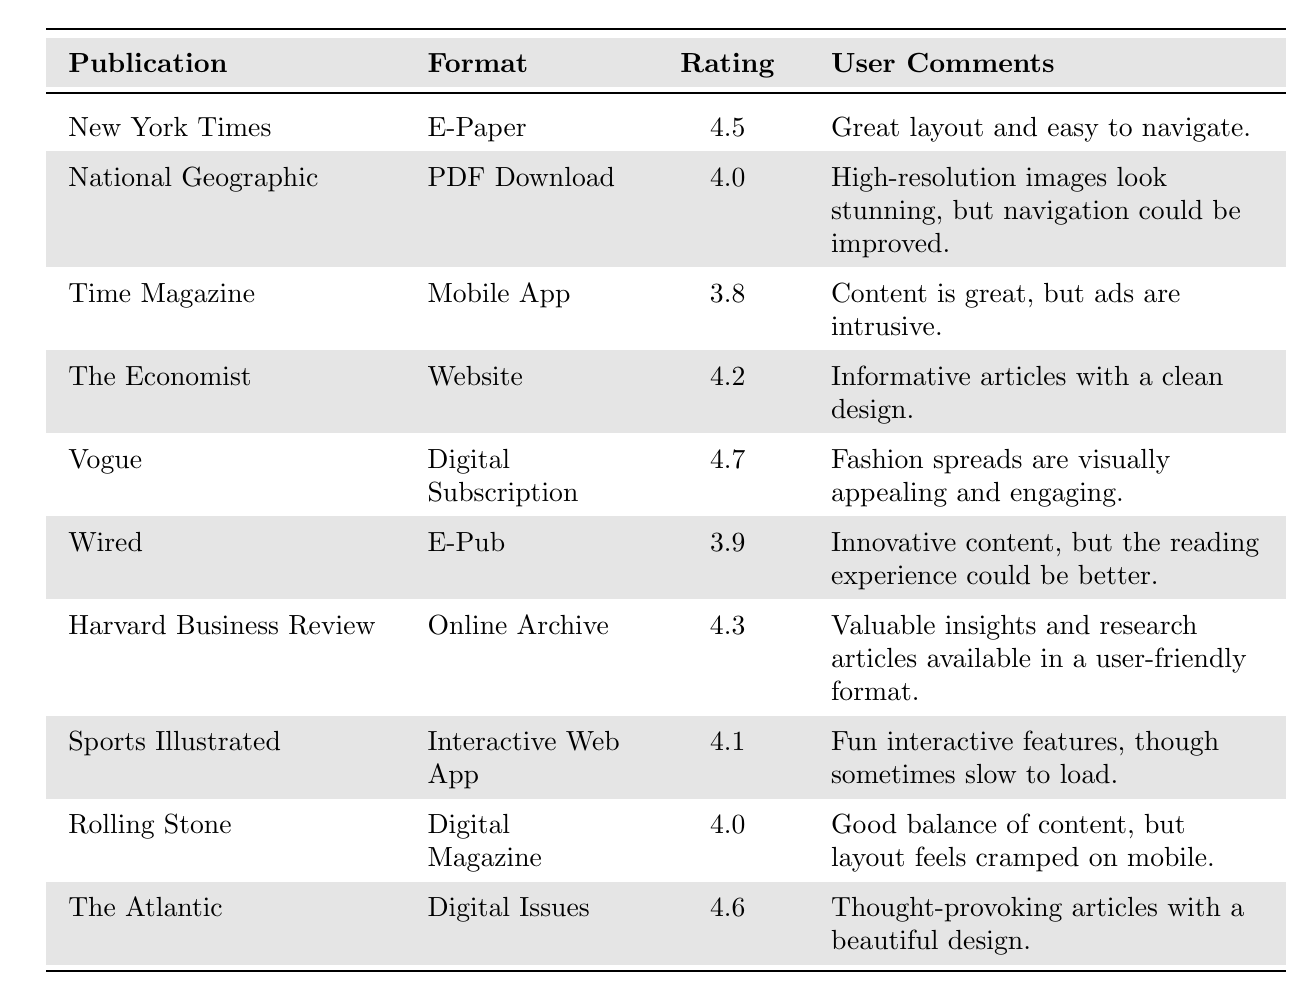What is the highest rating among the digital formats listed? The table shows ratings for each publication: 4.5 for New York Times, 4.0 for National Geographic, 3.8 for Time Magazine, 4.2 for The Economist, 4.7 for Vogue, 3.9 for Wired, 4.3 for Harvard Business Review, 4.1 for Sports Illustrated, 4.0 for Rolling Stone, and 4.6 for The Atlantic. The highest rating is 4.7 for Vogue.
Answer: 4.7 Which publication received a rating of 3.8? By checking the table, the only publication with a rating of 3.8 is Time Magazine, as listed under the Rating column.
Answer: Time Magazine What is the average rating of all publications listed? To calculate the average, we first sum all the ratings: 4.5 + 4.0 + 3.8 + 4.2 + 4.7 + 3.9 + 4.3 + 4.1 + 4.0 + 4.6 = 43.1. There are 10 publications, so we divide the total by 10: 43.1 / 10 = 4.31.
Answer: 4.31 Did the National Geographic receive a higher rating than Harvard Business Review? National Geographic has a rating of 4.0, and Harvard Business Review has a rating of 4.3. Since 4.0 is less than 4.3, National Geographic did not receive a higher rating.
Answer: No Which publication had comments regarding "clean design"? Referring to the comments in the table, The Economist mentions "Informative articles with a clean design."
Answer: The Economist What is the difference between the highest and the lowest ratings? The highest rating is 4.7 (Vogue) and the lowest is 3.8 (Time Magazine). The difference is calculated as 4.7 - 3.8 = 0.9.
Answer: 0.9 Is there a publication that received an average rating of 4.5 None of the listed publications has a rating of 4.5; the ratings are either higher or lower.
Answer: No Which formats have a rating higher than 4.0 and include user comments mentioning visual appeal? Checking the ratings above 4.0, Vogue (4.7) mentions "visually appealing" for its fashion spreads. The Atlantic (4.6) mentions "beautiful design", thus both meet the criteria.
Answer: Vogue and The Atlantic Which publication format is rated the lowest? By observing the ratings, Time Magazine has the lowest rating of 3.8 among the listed publications.
Answer: Time Magazine How many publications received ratings of 4.0 or higher? The publications with ratings of 4.0 or higher are: New York Times (4.5), National Geographic (4.0), The Economist (4.2), Vogue (4.7), Harvard Business Review (4.3), Sports Illustrated (4.1), Rolling Stone (4.0), and The Atlantic (4.6) totaling to 8 publications.
Answer: 8 